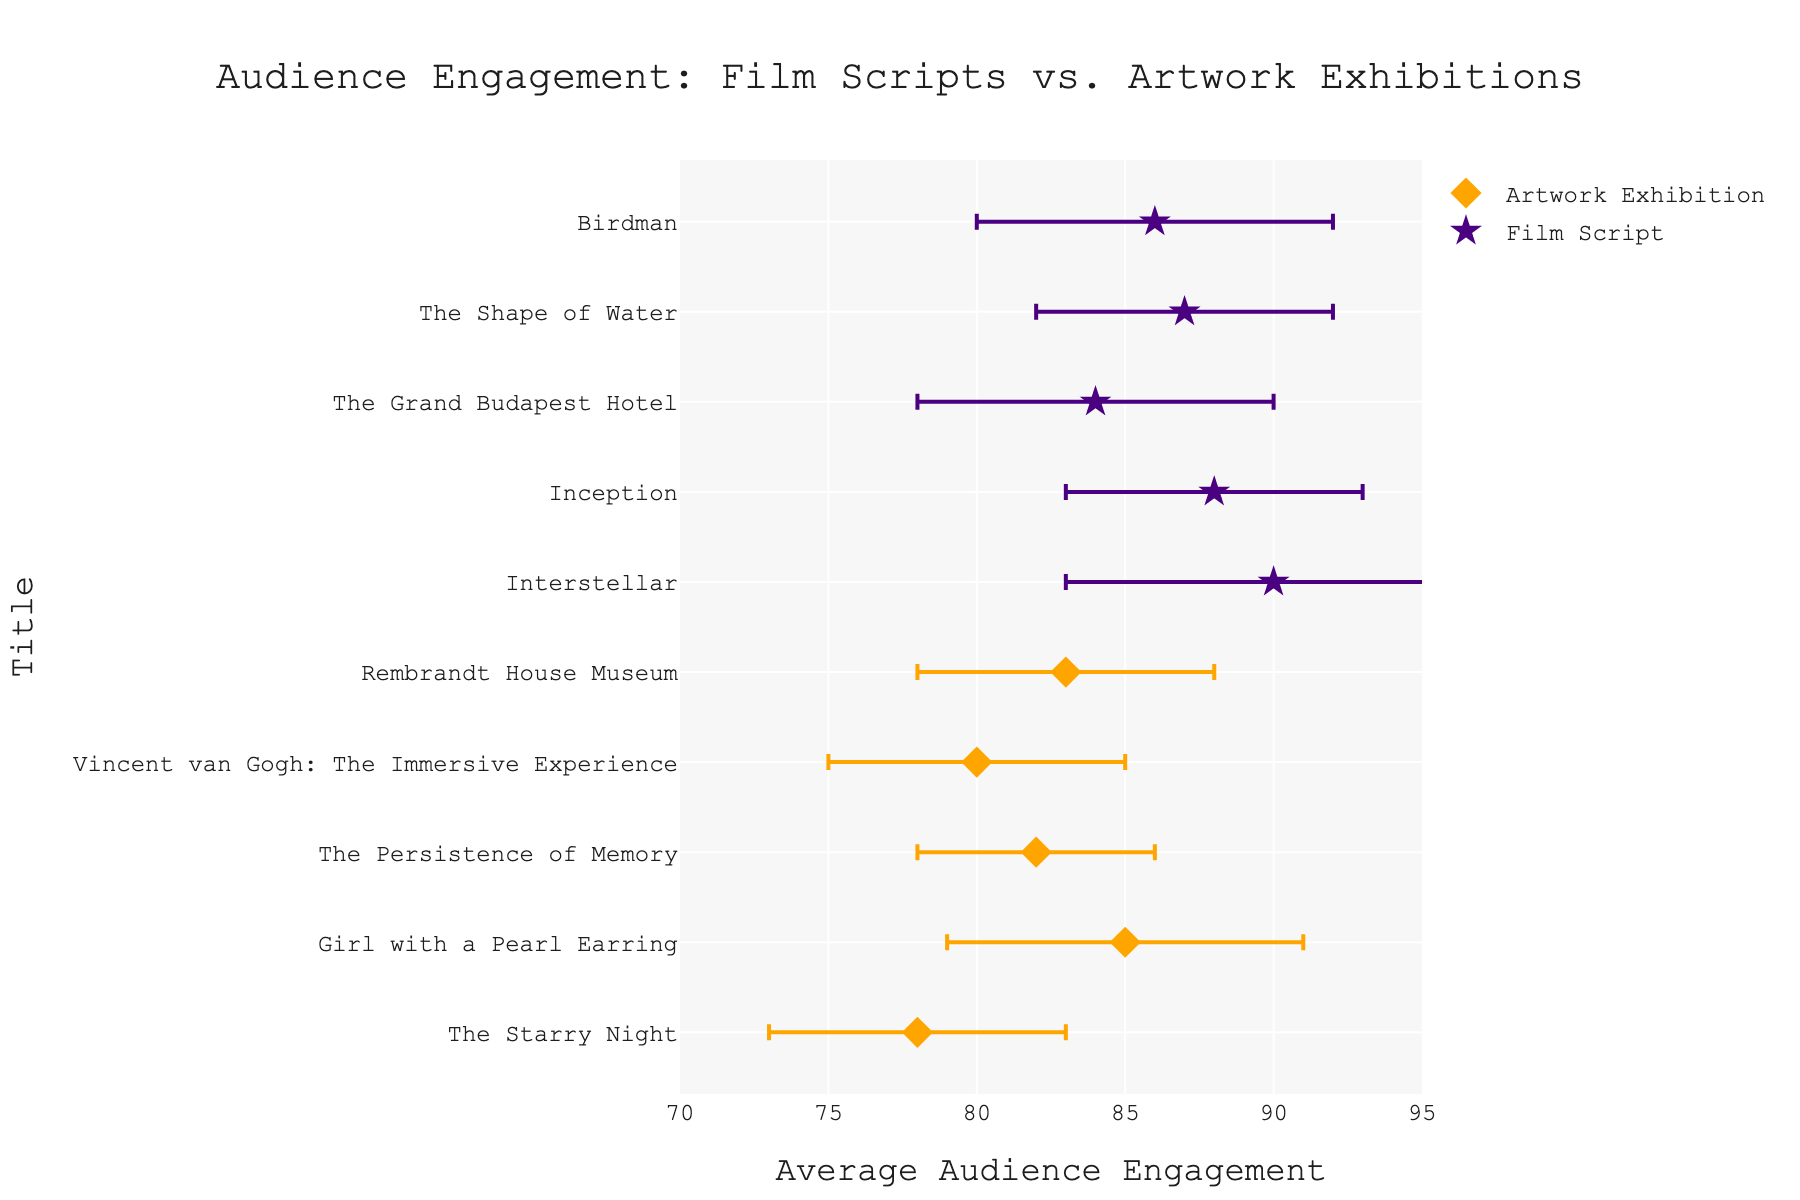What is the title of the figure? The title of the figure can be found at the top of the plot. It is displayed in a larger font size compared to other text elements in the figure. The title is "Audience Engagement: Film Scripts vs. Artwork Exhibitions".
Answer: Audience Engagement: Film Scripts vs. Artwork Exhibitions Which exhibits have audience engagement levels lower than 80? To determine exhibits with audience engagement levels lower than 80, look at the x-axis values for each point in the scatter plot. Only "The Starry Night" has an average engagement level below 80.
Answer: The Starry Night What is the range of average audience engagement for film scripts? To find the range, identify the lowest and highest x-axis values for film script data points. "The Grand Budapest Hotel" has the lowest engagement at 84, and "Interstellar" has the highest at 90. Subtract the smallest value from the largest value.
Answer: 6 How does the audience engagement of "Inception" compare to "Girl with a Pearl Earring"? Compare the x-axis values of "Inception" and "Girl with a Pearl Earring". "Inception" has an engagement level of 88, while "Girl with a Pearl Earring" has an engagement level of 85.
Answer: Inception has higher engagement than Girl with a Pearl Earring What is the engagement level difference between "The Persistence of Memory" and "Birdman"? Subtract the average audience engagement level of "The Persistence of Memory" (82) from that of "Birdman" (86).
Answer: 4 Which artwork exhibition has the highest average audience engagement? From the scatter plot, find the artwork exhibition data points and identify the one with the highest x-axis value. "Girl with a Pearl Earring" has the highest engagement at 85.
Answer: Girl with a Pearl Earring What is the combined average audience engagement of "Interstellar" and "Rembrandt House Museum"? Add the average audience engagement levels of "Interstellar" (90) and "Rembrandt House Museum" (83), then divide by 2 to find the average.
Answer: 86.5 Which film script has the smallest variability in audience engagement? Look at the error bars for each film script data point. The film script with the smallest error bar (standard deviation) is "Inception" with a standard deviation of 5.
Answer: Inception How many artwork exhibitions are represented in the figure? Count the number of data points labeled as "Artwork Exhibition" in the figure. There are five: "The Starry Night", "Girl with a Pearl Earring", "The Persistence of Memory", "Vincent van Gogh: The Immersive Experience", and "Rembrandt House Museum".
Answer: 5 Which data points fall within the interquartile range (IQR) of average engagement for film scripts? First, list the engagement values for film scripts: {90, 88, 84, 87, 86}. Order them: {84, 86, 87, 88, 90}. The IQR is between the first quartile (86) and the third quartile (88). Identify data points within this range: "The Shape of Water" and "Birdman".
Answer: The Shape of Water, Birdman 